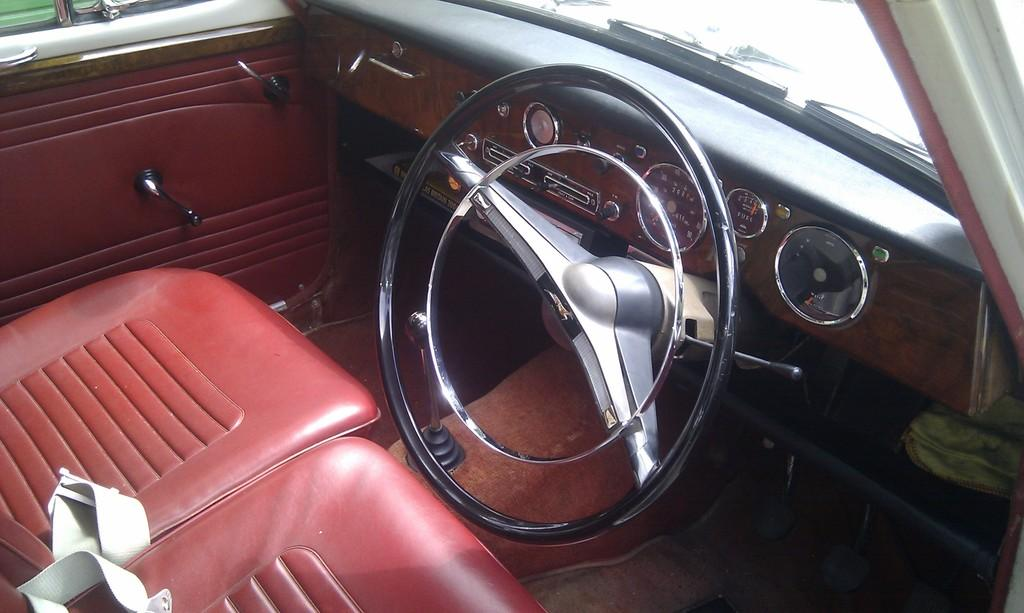What is the main subject of the image? The main subject of the image is a car. What can be said about the color of the seats in the car? The car has red color seats. What is the color of the steering wheel in the car? The car has a black color steering wheel. Can you describe any visible doors in the image? There is a door visible in the image. What is present on the right side of the car? There is a windshield on the right side of the car. What is attached to the windshield on the right side of the car? There is a wiper on the right side of the windshield. What type of lunch is being served to the passenger in the image? There is no passenger or lunch present in the image; it only features a car with specific details. 